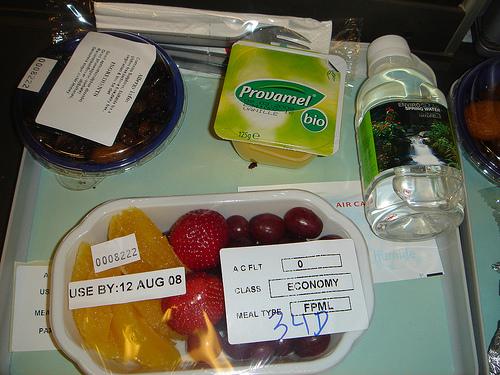<image>
Can you confirm if the bottle is behind the tray? No. The bottle is not behind the tray. From this viewpoint, the bottle appears to be positioned elsewhere in the scene. Is the bottle behind the package? No. The bottle is not behind the package. From this viewpoint, the bottle appears to be positioned elsewhere in the scene. Where is the strawberry in relation to the dish? Is it in the dish? Yes. The strawberry is contained within or inside the dish, showing a containment relationship. 